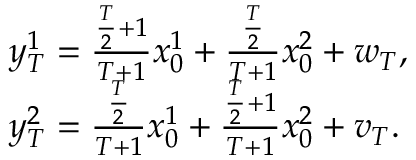<formula> <loc_0><loc_0><loc_500><loc_500>\begin{array} { r l } & { y _ { T } ^ { 1 } = \frac { \frac { T } { 2 } + 1 } { T + 1 } x _ { 0 } ^ { 1 } + \frac { \frac { T } { 2 } } { T + 1 } x _ { 0 } ^ { 2 } + w _ { T } , } \\ & { y _ { T } ^ { 2 } = \frac { \frac { T } { 2 } } { T + 1 } x _ { 0 } ^ { 1 } + \frac { \frac { T } { 2 } + 1 } { T + 1 } x _ { 0 } ^ { 2 } + v _ { T } . } \end{array}</formula> 